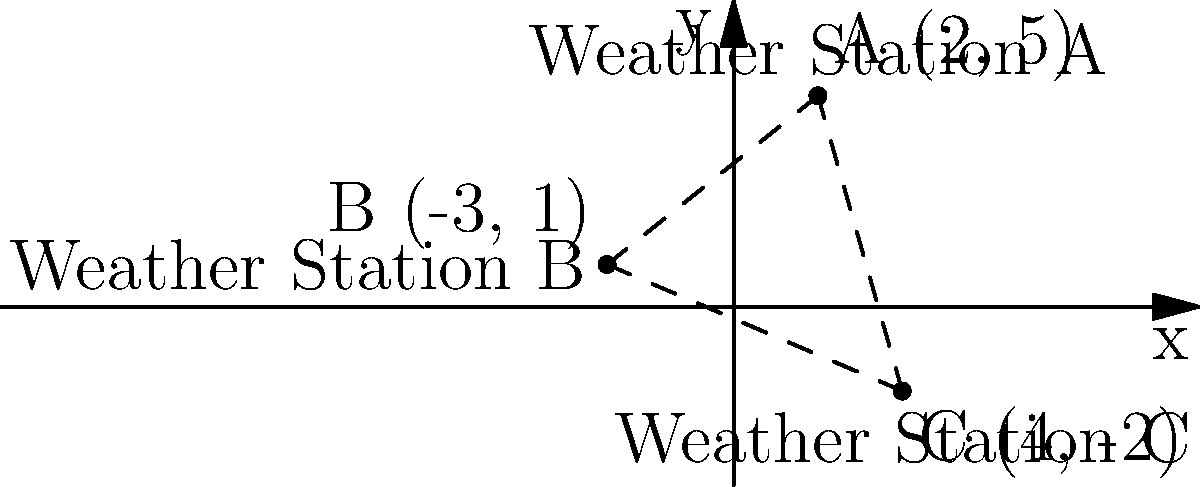As a retired weatherman, you're helping set up a new weather monitoring system. Three weather stations A, B, and C are located on a coordinate plane as shown in the diagram. Station A is at (2, 5), B at (-3, 1), and C at (4, -2). Calculate the total distance between all three stations (A to B, B to C, and A to C) to determine the coverage area of the monitoring system. Round your answer to the nearest kilometer. To solve this problem, we need to calculate the distances between each pair of stations using the distance formula and then sum them up. Let's go through it step-by-step:

1. Distance formula: $d = \sqrt{(x_2-x_1)^2 + (y_2-y_1)^2}$

2. Calculate distance between A and B:
   $d_{AB} = \sqrt{(-3-2)^2 + (1-5)^2} = \sqrt{(-5)^2 + (-4)^2} = \sqrt{25 + 16} = \sqrt{41} \approx 6.40$ km

3. Calculate distance between B and C:
   $d_{BC} = \sqrt{(4-(-3))^2 + (-2-1)^2} = \sqrt{7^2 + (-3)^2} = \sqrt{49 + 9} = \sqrt{58} \approx 7.62$ km

4. Calculate distance between A and C:
   $d_{AC} = \sqrt{(4-2)^2 + (-2-5)^2} = \sqrt{2^2 + (-7)^2} = \sqrt{4 + 49} = \sqrt{53} \approx 7.28$ km

5. Sum up all distances:
   Total distance = $d_{AB} + d_{BC} + d_{AC} = 6.40 + 7.62 + 7.28 = 21.30$ km

6. Round to the nearest kilometer:
   21.30 km ≈ 21 km

Therefore, the total distance between all three weather stations, rounded to the nearest kilometer, is 21 km.
Answer: 21 km 